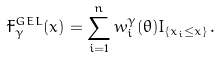<formula> <loc_0><loc_0><loc_500><loc_500>\tilde { F } ^ { G E L } _ { \gamma } ( x ) = \sum _ { i = 1 } ^ { n } w ^ { \gamma } _ { i } ( \theta ) I _ { \{ x _ { i } \leq x \} } \, .</formula> 